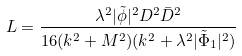Convert formula to latex. <formula><loc_0><loc_0><loc_500><loc_500>L = \frac { \lambda ^ { 2 } | \tilde { \phi } | ^ { 2 } D ^ { 2 } \bar { D } ^ { 2 } } { 1 6 ( k ^ { 2 } + M ^ { 2 } ) ( k ^ { 2 } + \lambda ^ { 2 } | \tilde { \Phi } _ { 1 } | ^ { 2 } ) }</formula> 